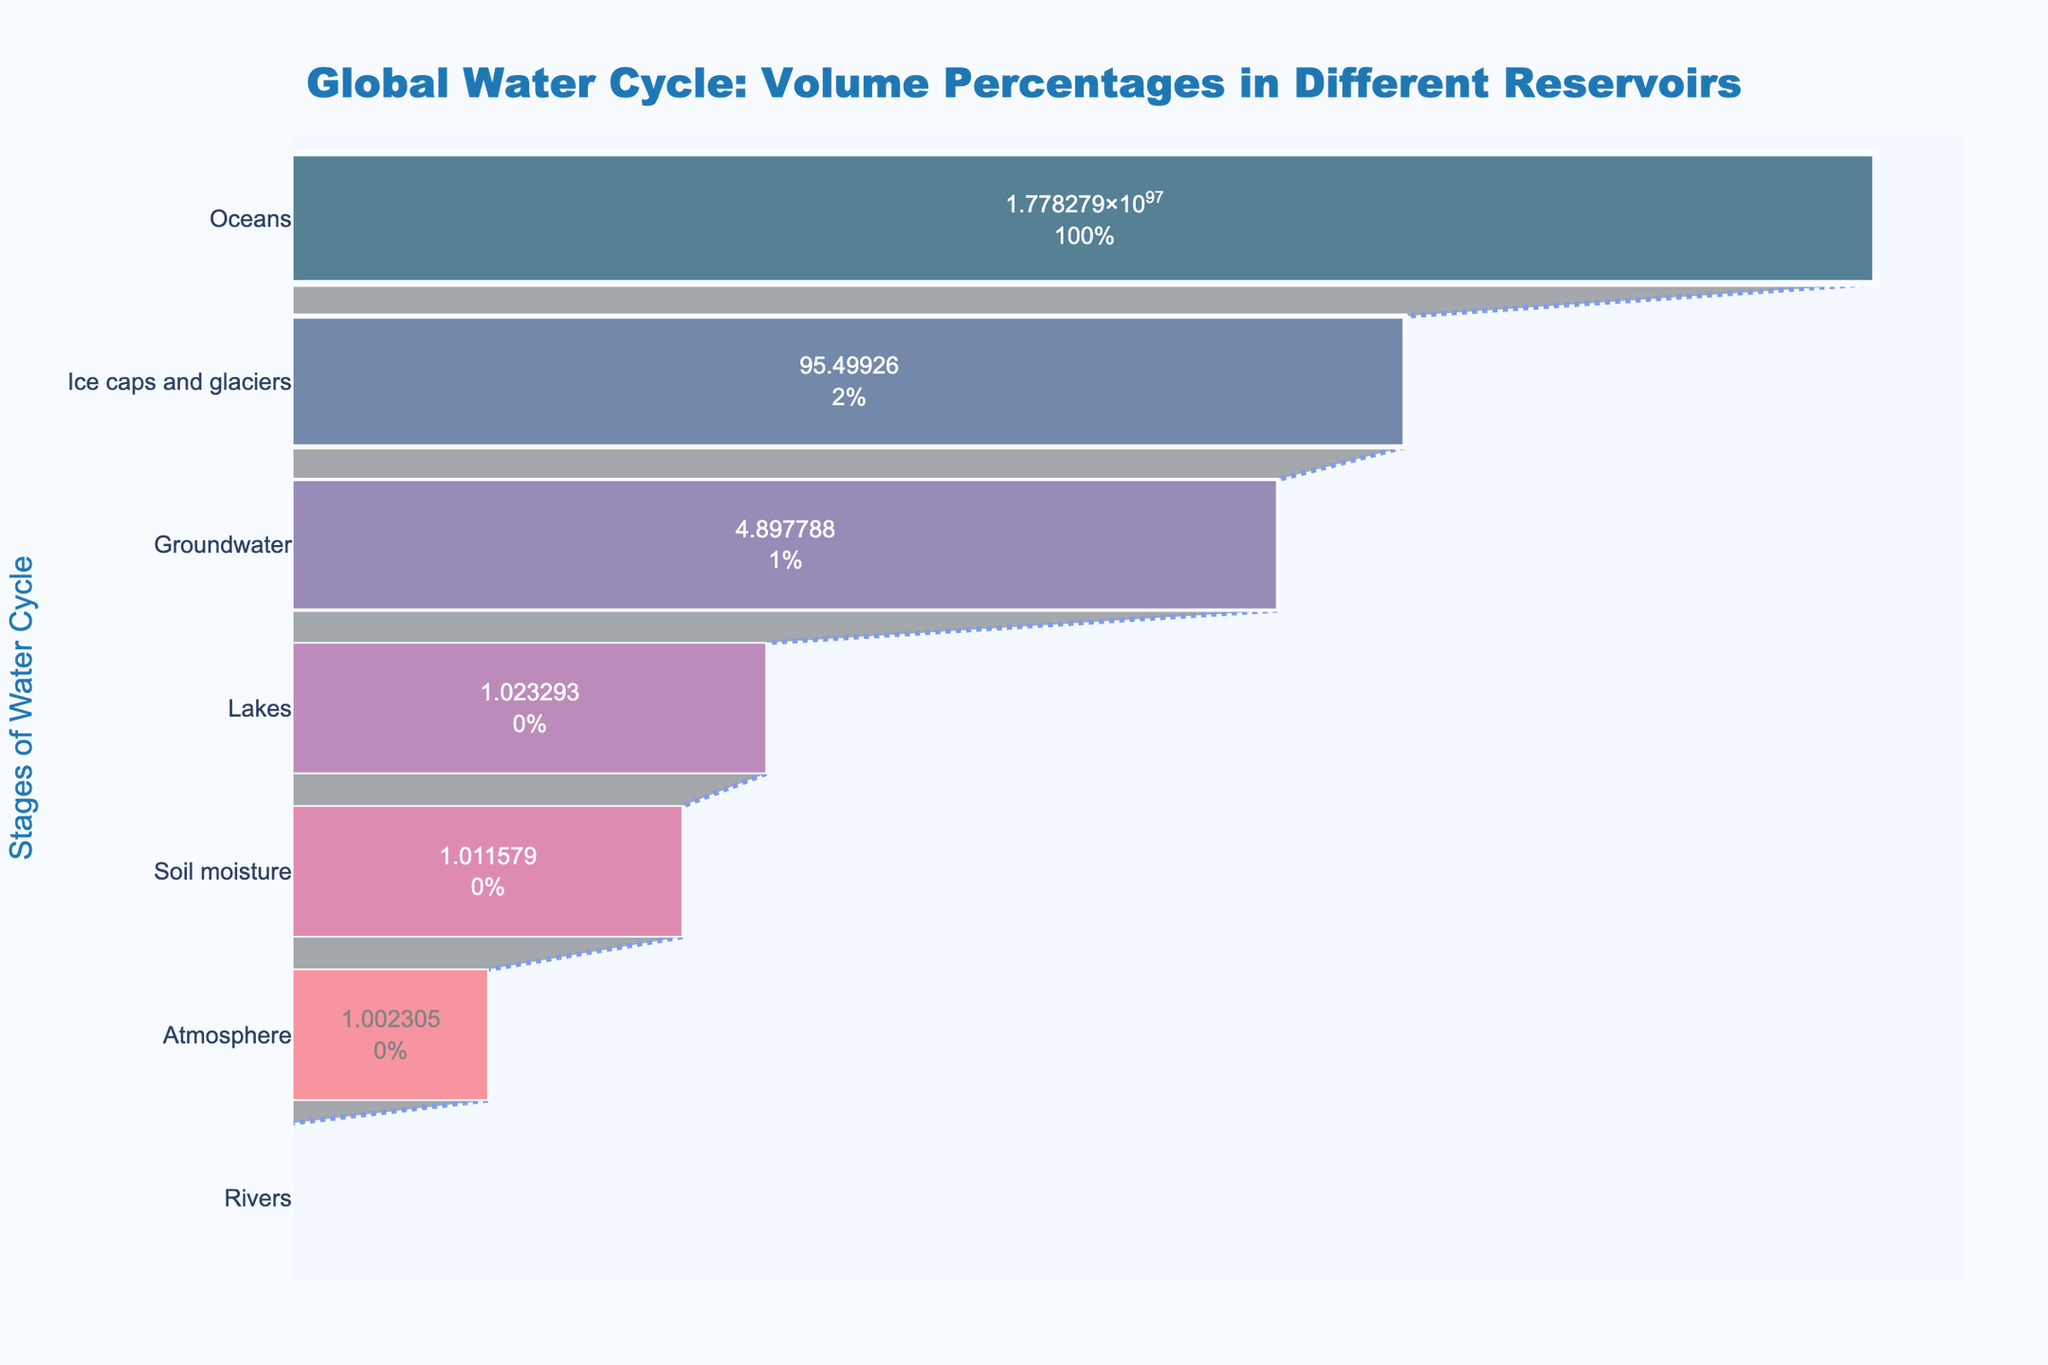What is the title of the figure? The title of the figure is displayed at the top of the chart. It is clearly labeled to provide context about what the chart represents.
Answer: Global Water Cycle: Volume Percentages in Different Reservoirs How many stages are represented in the funnel chart? To determine the number of stages, we look at the different labels on the y-axis. Each unique label corresponds to a different stage.
Answer: 7 Which stage has the largest volume percentage? We identify the stage with the largest bar at the top of the funnel chart. The label corresponding to this bar represents the stage with the largest volume percentage.
Answer: Oceans What is the total volume percentage of Ice caps and glaciers and Groundwater combined? We add the volume percentages for Ice caps and glaciers (1.98%) and Groundwater (0.69%). So, 1.98 + 0.69 = 2.67%.
Answer: 2.67% Which two stages have the smallest volume percentages? By examining the two smallest sections at the bottom of the funnel chart, we identify the stages corresponding to these sections.
Answer: Rivers and Atmosphere How does the volume percentage of Lakes compare to that of Groundwater? We compare the length of the bars for Lakes and Groundwater. From the chart, Lakes have a smaller volume percentage than Groundwater.
Answer: Lakes are smaller What is the difference in volume percentage between Soil moisture and Rivers? We subtract the volume percentage of Rivers (0.0001%) from that of Soil moisture (0.005%), giving us 0.005 - 0.0001 = 0.0049%.
Answer: 0.0049% Rank the stages in descending order of their volume percentages. We list the stages from the largest to the smallest bar seen in the chart. The order is Oceans, Ice caps and glaciers, Groundwater, Lakes, Soil moisture, Atmosphere, and Rivers.
Answer: Oceans, Ice caps and glaciers, Groundwater, Lakes, Soil moisture, Atmosphere, Rivers Which stage has a volume percentage closest to 1%? By reviewing the volume percentages, we identify the stage that is nearest to 1%.
Answer: Ice caps and glaciers If the volume percentage of the Oceans were to decrease by 2%, what would be its new volume percentage? We subtract 2% from the original volume percentage of Oceans (97.25%). So, 97.25 - 2 = 95.25%.
Answer: 95.25% 